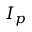<formula> <loc_0><loc_0><loc_500><loc_500>I _ { p }</formula> 